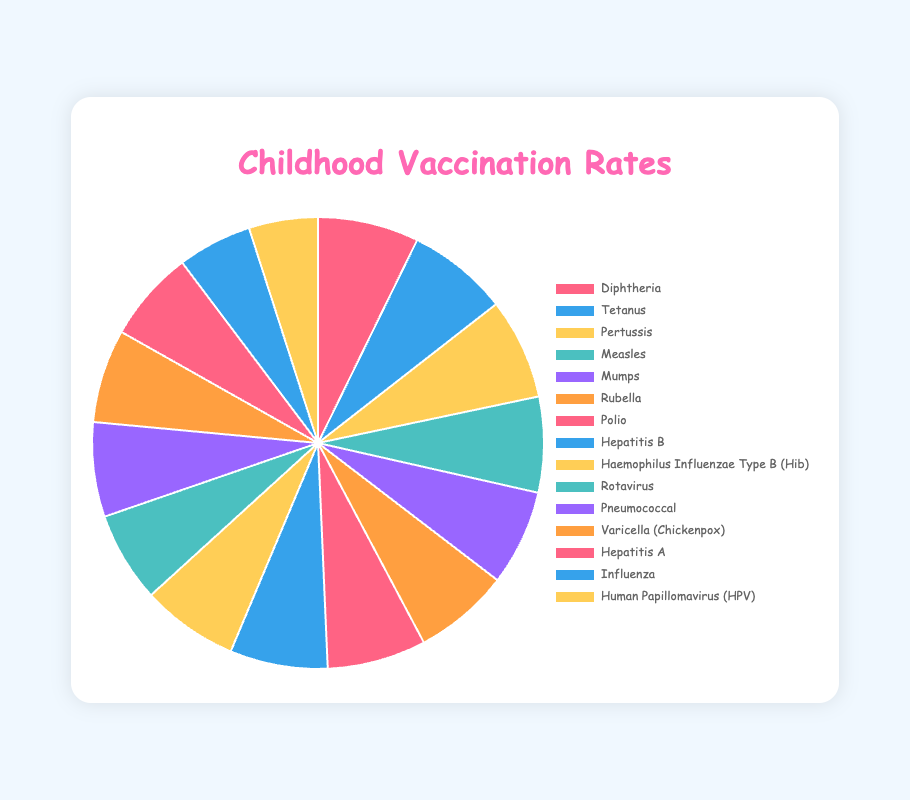What is the vaccination rate for Measles? To find the vaccination rate for Measles, look at the section labeled 'Measles' in the pie chart. It shows the value directly next to the label.
Answer: 90% Which vaccine has the lowest vaccination rate? Identify the segment with the lowest proportion in the pie chart and check its label.
Answer: Human Papillomavirus (HPV) How much higher is the vaccination rate for Diphtheria compared to Influenza? Locate the vaccination rates for Diphtheria (95%) and Influenza (70%) and subtract the latter from the former: 95% - 70% = 25%
Answer: 25% What is the total of the vaccination rates for Rotavirus, Pneumococcal, and Varicella? Add the vaccination rates for Rotavirus (85%), Pneumococcal (89%), and Varicella (88%): 85% + 89% + 88% = 262%
Answer: 262% Are there any vaccines with the same vaccination rates? Compare the vaccination rates and see if any values are repeated. Diphtheria, Tetanus, and Pertussis all have vaccination rates of 95%, and Measles, Mumps, and Rubella each have rates of 90%.
Answer: Yes How does the vaccination rate for Polio compare to Hepatitis B? Check the vaccination rates for both Polio (93%) and Hepatitis B (92%) and compare them. Polio has a slightly higher rate than Hepatitis B.
Answer: Polio is higher What is the average vaccination rate for the three vaccines with the highest rates? Identify the three highest rates (Diphtheria 95%, Tetanus 95%, Pertussis 95%) and calculate their average: (95% + 95% + 95%) / 3 = 95%
Answer: 95% What color represents Rubella in the pie chart? Look for the Rubella section in the pie chart and describe its color by comparing to other familiar colors.
Answer: Purple How does the vaccination rate for Varicella compare to the average rate for all vaccines? Sum the vaccination rates and divide by the number of vaccines to find the average: (95+95+95+90+90+90+93+92+91+85+89+88+86+70+65)/15 = ~86%. Compare Varicella (88%) to this average. Varicella is 2% higher.
Answer: Varicella is higher What is the combined vaccination rate for all vaccines except Influenza and HPV? Sum all vaccination rates except Influenza (70%) and HPV (65%): 95+95+95+90+90+90+93+92+91+85+89+88+86 = 1084%
Answer: 1084% 